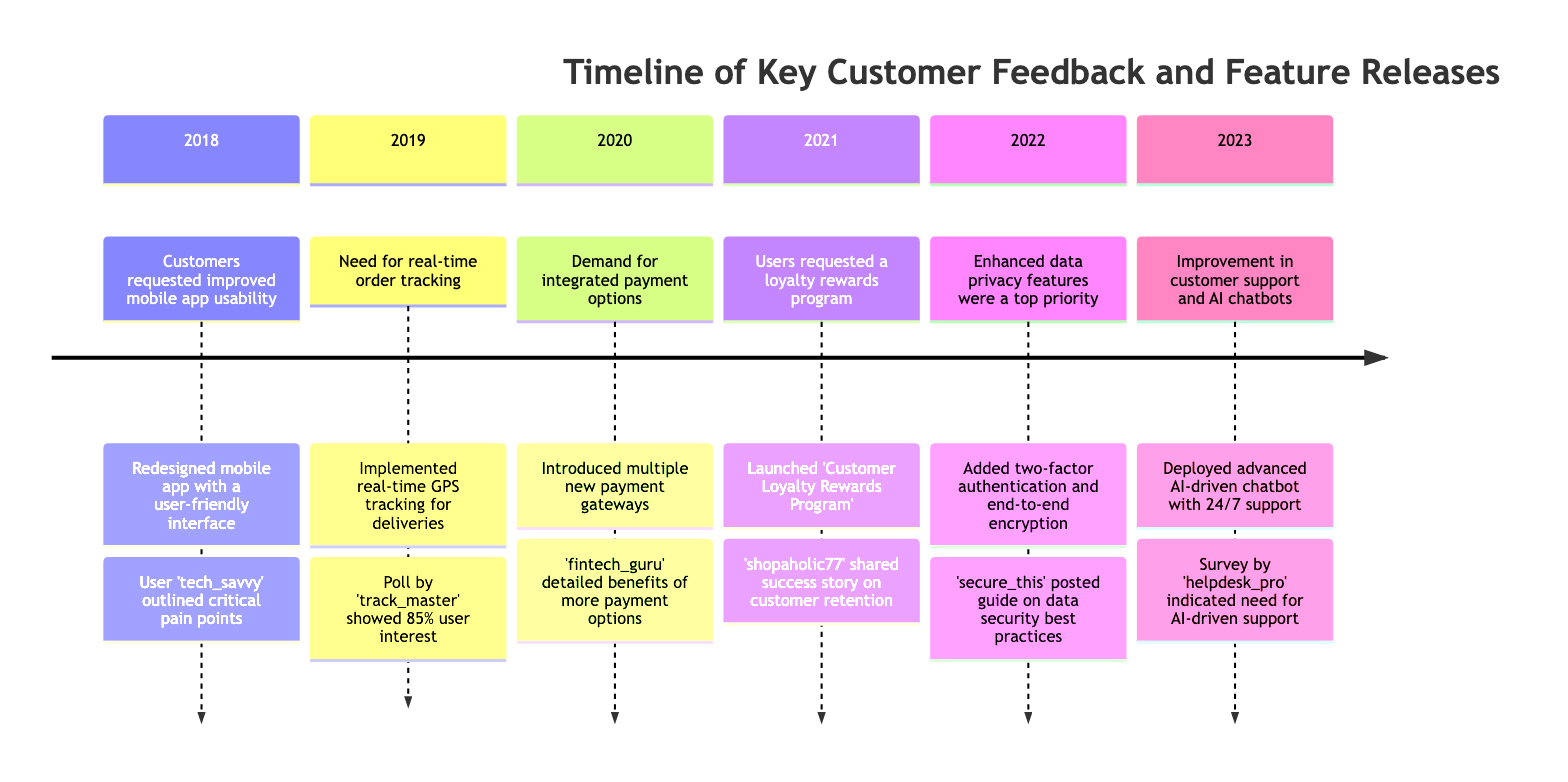What feedback was received in 2020? The diagram indicates that in 2020, customer feedback highlighted the demand for integrated payment options. This information is found in the section for the year 2020, which specifically cites this request.
Answer: Demand for integrated payment options Which feature was released in Q3 2019? According to the timeline, the feature implemented in Q3 2019 was real-time GPS tracking for deliveries. This can be identified in the section for the year 2019 under the corresponding feature release.
Answer: Implemented real-time GPS tracking for deliveries Who initiated the thread for mobile app usability feedback? The diagram shows that the thread regarding improved mobile app usability was initiated by 'tech_savvy'. This information is found in the 2018 section as the user contribution linked to that feedback.
Answer: tech_savvy What was the user contribution for the 2021 feedback? The user contribution listed for the 2021 feedback about a loyalty rewards program was a success story shared by 'shopaholic77'. This is clearly stated in the 2021 section of the diagram.
Answer: 'shopaholic77' shared success story on customer retention How many years does the timeline cover? By examining the timeline, it starts from 2018 and goes through 2023, covering a total of six years. To find this, you count the years listed from the beginning to the end.
Answer: 6 What significant change was implemented in Q2 2022? The significant change implemented in Q2 2022 was the addition of two-factor authentication and end-to-end encryption for data privacy. This information can be found in the section designated for that year.
Answer: Added two-factor authentication and end-to-end encryption 